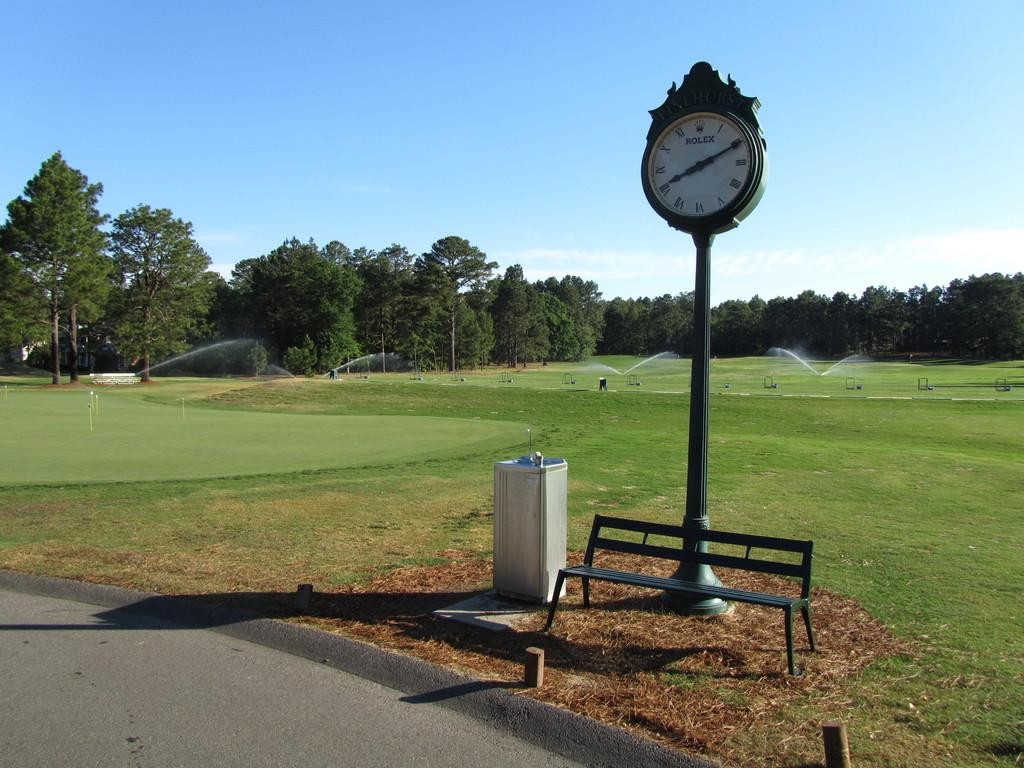Provide a one-sentence caption for the provided image. A Rolex clock is outside next to a garbage can and behind a bench. 